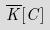Convert formula to latex. <formula><loc_0><loc_0><loc_500><loc_500>\overline { K } [ C ]</formula> 